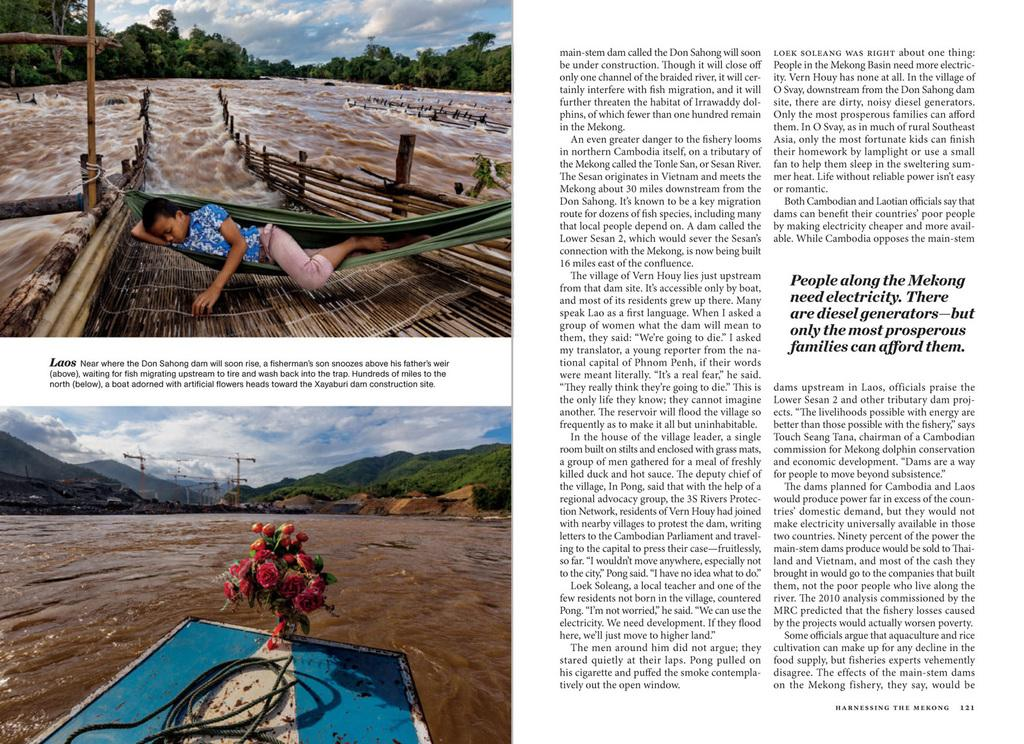What is present on the paper in the image? There are two images and writing on the paper. How many images can be seen on the paper? There are two images on the paper. What can be found alongside the images on the paper? There is writing on the paper. What type of scent can be detected from the paper in the image? There is no mention of a scent in the image, so it cannot be determined from the image. 